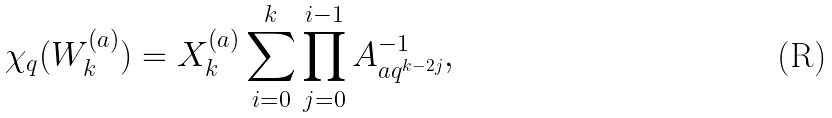Convert formula to latex. <formula><loc_0><loc_0><loc_500><loc_500>\chi _ { q } ( W _ { k } ^ { ( a ) } ) = X _ { k } ^ { ( a ) } \sum _ { i = 0 } ^ { k } \prod _ { j = 0 } ^ { i - 1 } A _ { a q ^ { k - 2 j } } ^ { - 1 } ,</formula> 